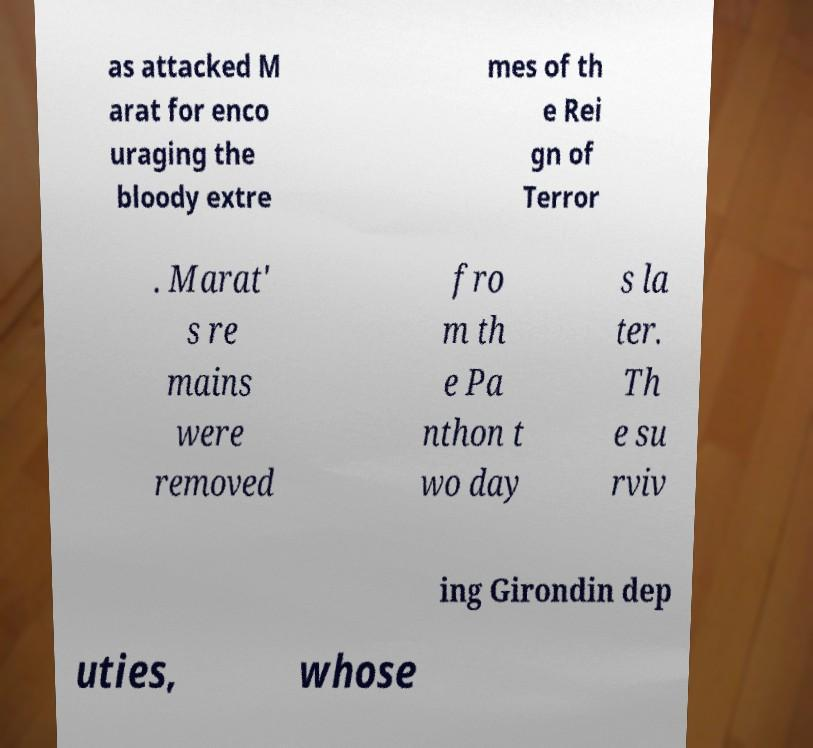Can you read and provide the text displayed in the image?This photo seems to have some interesting text. Can you extract and type it out for me? as attacked M arat for enco uraging the bloody extre mes of th e Rei gn of Terror . Marat' s re mains were removed fro m th e Pa nthon t wo day s la ter. Th e su rviv ing Girondin dep uties, whose 